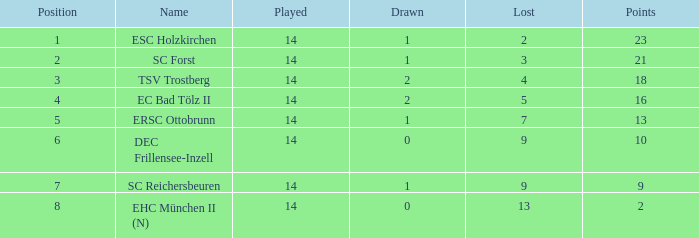For games with 2 losses and played fewer than 14 times, how many ended in a draw? None. 